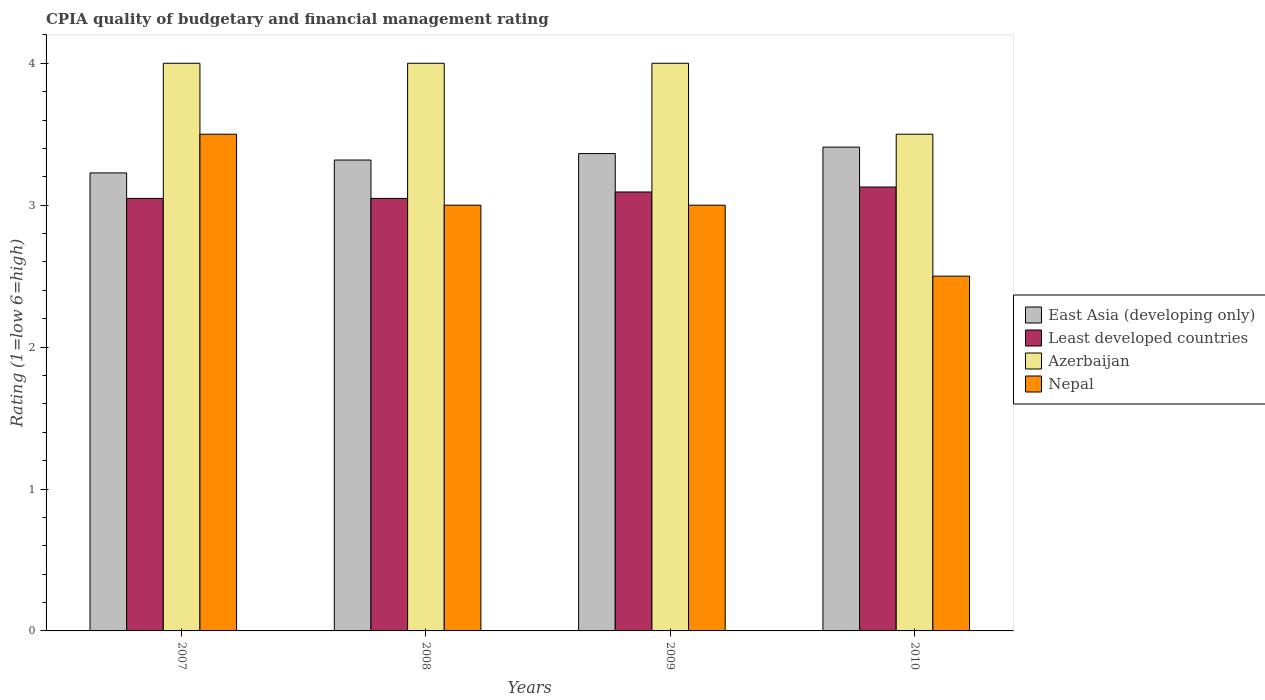How many groups of bars are there?
Provide a short and direct response. 4. Are the number of bars on each tick of the X-axis equal?
Provide a succinct answer. Yes. What is the label of the 1st group of bars from the left?
Offer a terse response. 2007. In how many cases, is the number of bars for a given year not equal to the number of legend labels?
Your response must be concise. 0. What is the CPIA rating in East Asia (developing only) in 2008?
Your answer should be very brief. 3.32. Across all years, what is the maximum CPIA rating in Least developed countries?
Your answer should be compact. 3.13. Across all years, what is the minimum CPIA rating in East Asia (developing only)?
Offer a very short reply. 3.23. In which year was the CPIA rating in Nepal minimum?
Ensure brevity in your answer.  2010. What is the total CPIA rating in Least developed countries in the graph?
Offer a terse response. 12.32. What is the difference between the CPIA rating in Least developed countries in 2008 and that in 2009?
Your response must be concise. -0.05. What is the difference between the CPIA rating in East Asia (developing only) in 2010 and the CPIA rating in Nepal in 2009?
Ensure brevity in your answer.  0.41. What is the average CPIA rating in East Asia (developing only) per year?
Give a very brief answer. 3.33. In the year 2008, what is the difference between the CPIA rating in East Asia (developing only) and CPIA rating in Least developed countries?
Make the answer very short. 0.27. What is the ratio of the CPIA rating in Least developed countries in 2009 to that in 2010?
Offer a terse response. 0.99. Is the CPIA rating in Least developed countries in 2009 less than that in 2010?
Offer a terse response. Yes. Is the difference between the CPIA rating in East Asia (developing only) in 2008 and 2010 greater than the difference between the CPIA rating in Least developed countries in 2008 and 2010?
Your answer should be compact. No. What is the difference between the highest and the lowest CPIA rating in East Asia (developing only)?
Your response must be concise. 0.18. In how many years, is the CPIA rating in East Asia (developing only) greater than the average CPIA rating in East Asia (developing only) taken over all years?
Provide a succinct answer. 2. What does the 2nd bar from the left in 2010 represents?
Your response must be concise. Least developed countries. What does the 4th bar from the right in 2009 represents?
Provide a short and direct response. East Asia (developing only). Is it the case that in every year, the sum of the CPIA rating in Least developed countries and CPIA rating in Nepal is greater than the CPIA rating in Azerbaijan?
Ensure brevity in your answer.  Yes. How many bars are there?
Keep it short and to the point. 16. How many years are there in the graph?
Your response must be concise. 4. What is the difference between two consecutive major ticks on the Y-axis?
Offer a very short reply. 1. Are the values on the major ticks of Y-axis written in scientific E-notation?
Provide a short and direct response. No. Does the graph contain any zero values?
Your response must be concise. No. How many legend labels are there?
Offer a terse response. 4. What is the title of the graph?
Offer a very short reply. CPIA quality of budgetary and financial management rating. What is the label or title of the X-axis?
Ensure brevity in your answer.  Years. What is the Rating (1=low 6=high) in East Asia (developing only) in 2007?
Keep it short and to the point. 3.23. What is the Rating (1=low 6=high) in Least developed countries in 2007?
Provide a succinct answer. 3.05. What is the Rating (1=low 6=high) of Azerbaijan in 2007?
Give a very brief answer. 4. What is the Rating (1=low 6=high) in Nepal in 2007?
Provide a short and direct response. 3.5. What is the Rating (1=low 6=high) in East Asia (developing only) in 2008?
Keep it short and to the point. 3.32. What is the Rating (1=low 6=high) in Least developed countries in 2008?
Provide a short and direct response. 3.05. What is the Rating (1=low 6=high) in Azerbaijan in 2008?
Your answer should be very brief. 4. What is the Rating (1=low 6=high) in Nepal in 2008?
Give a very brief answer. 3. What is the Rating (1=low 6=high) in East Asia (developing only) in 2009?
Give a very brief answer. 3.36. What is the Rating (1=low 6=high) in Least developed countries in 2009?
Offer a very short reply. 3.09. What is the Rating (1=low 6=high) in Azerbaijan in 2009?
Ensure brevity in your answer.  4. What is the Rating (1=low 6=high) of Nepal in 2009?
Provide a short and direct response. 3. What is the Rating (1=low 6=high) in East Asia (developing only) in 2010?
Your answer should be very brief. 3.41. What is the Rating (1=low 6=high) in Least developed countries in 2010?
Your response must be concise. 3.13. What is the Rating (1=low 6=high) of Azerbaijan in 2010?
Provide a short and direct response. 3.5. Across all years, what is the maximum Rating (1=low 6=high) in East Asia (developing only)?
Offer a very short reply. 3.41. Across all years, what is the maximum Rating (1=low 6=high) in Least developed countries?
Keep it short and to the point. 3.13. Across all years, what is the maximum Rating (1=low 6=high) in Nepal?
Offer a very short reply. 3.5. Across all years, what is the minimum Rating (1=low 6=high) of East Asia (developing only)?
Your answer should be very brief. 3.23. Across all years, what is the minimum Rating (1=low 6=high) of Least developed countries?
Offer a very short reply. 3.05. Across all years, what is the minimum Rating (1=low 6=high) in Nepal?
Offer a terse response. 2.5. What is the total Rating (1=low 6=high) of East Asia (developing only) in the graph?
Your answer should be very brief. 13.32. What is the total Rating (1=low 6=high) of Least developed countries in the graph?
Make the answer very short. 12.32. What is the total Rating (1=low 6=high) in Azerbaijan in the graph?
Offer a very short reply. 15.5. What is the total Rating (1=low 6=high) of Nepal in the graph?
Make the answer very short. 12. What is the difference between the Rating (1=low 6=high) in East Asia (developing only) in 2007 and that in 2008?
Offer a very short reply. -0.09. What is the difference between the Rating (1=low 6=high) of Azerbaijan in 2007 and that in 2008?
Provide a short and direct response. 0. What is the difference between the Rating (1=low 6=high) of Nepal in 2007 and that in 2008?
Offer a very short reply. 0.5. What is the difference between the Rating (1=low 6=high) in East Asia (developing only) in 2007 and that in 2009?
Offer a terse response. -0.14. What is the difference between the Rating (1=low 6=high) of Least developed countries in 2007 and that in 2009?
Your answer should be very brief. -0.05. What is the difference between the Rating (1=low 6=high) in Azerbaijan in 2007 and that in 2009?
Offer a very short reply. 0. What is the difference between the Rating (1=low 6=high) in East Asia (developing only) in 2007 and that in 2010?
Your answer should be very brief. -0.18. What is the difference between the Rating (1=low 6=high) of Least developed countries in 2007 and that in 2010?
Make the answer very short. -0.08. What is the difference between the Rating (1=low 6=high) in Nepal in 2007 and that in 2010?
Keep it short and to the point. 1. What is the difference between the Rating (1=low 6=high) in East Asia (developing only) in 2008 and that in 2009?
Your response must be concise. -0.05. What is the difference between the Rating (1=low 6=high) in Least developed countries in 2008 and that in 2009?
Ensure brevity in your answer.  -0.05. What is the difference between the Rating (1=low 6=high) in Azerbaijan in 2008 and that in 2009?
Provide a succinct answer. 0. What is the difference between the Rating (1=low 6=high) in East Asia (developing only) in 2008 and that in 2010?
Your answer should be compact. -0.09. What is the difference between the Rating (1=low 6=high) of Least developed countries in 2008 and that in 2010?
Provide a succinct answer. -0.08. What is the difference between the Rating (1=low 6=high) in Nepal in 2008 and that in 2010?
Ensure brevity in your answer.  0.5. What is the difference between the Rating (1=low 6=high) of East Asia (developing only) in 2009 and that in 2010?
Make the answer very short. -0.05. What is the difference between the Rating (1=low 6=high) in Least developed countries in 2009 and that in 2010?
Ensure brevity in your answer.  -0.03. What is the difference between the Rating (1=low 6=high) of Azerbaijan in 2009 and that in 2010?
Provide a short and direct response. 0.5. What is the difference between the Rating (1=low 6=high) of Nepal in 2009 and that in 2010?
Your answer should be very brief. 0.5. What is the difference between the Rating (1=low 6=high) of East Asia (developing only) in 2007 and the Rating (1=low 6=high) of Least developed countries in 2008?
Ensure brevity in your answer.  0.18. What is the difference between the Rating (1=low 6=high) of East Asia (developing only) in 2007 and the Rating (1=low 6=high) of Azerbaijan in 2008?
Provide a succinct answer. -0.77. What is the difference between the Rating (1=low 6=high) in East Asia (developing only) in 2007 and the Rating (1=low 6=high) in Nepal in 2008?
Provide a succinct answer. 0.23. What is the difference between the Rating (1=low 6=high) of Least developed countries in 2007 and the Rating (1=low 6=high) of Azerbaijan in 2008?
Your answer should be compact. -0.95. What is the difference between the Rating (1=low 6=high) in Least developed countries in 2007 and the Rating (1=low 6=high) in Nepal in 2008?
Keep it short and to the point. 0.05. What is the difference between the Rating (1=low 6=high) in Azerbaijan in 2007 and the Rating (1=low 6=high) in Nepal in 2008?
Make the answer very short. 1. What is the difference between the Rating (1=low 6=high) of East Asia (developing only) in 2007 and the Rating (1=low 6=high) of Least developed countries in 2009?
Provide a succinct answer. 0.13. What is the difference between the Rating (1=low 6=high) in East Asia (developing only) in 2007 and the Rating (1=low 6=high) in Azerbaijan in 2009?
Offer a terse response. -0.77. What is the difference between the Rating (1=low 6=high) of East Asia (developing only) in 2007 and the Rating (1=low 6=high) of Nepal in 2009?
Make the answer very short. 0.23. What is the difference between the Rating (1=low 6=high) of Least developed countries in 2007 and the Rating (1=low 6=high) of Azerbaijan in 2009?
Your answer should be very brief. -0.95. What is the difference between the Rating (1=low 6=high) in Least developed countries in 2007 and the Rating (1=low 6=high) in Nepal in 2009?
Your response must be concise. 0.05. What is the difference between the Rating (1=low 6=high) of East Asia (developing only) in 2007 and the Rating (1=low 6=high) of Least developed countries in 2010?
Your answer should be compact. 0.1. What is the difference between the Rating (1=low 6=high) of East Asia (developing only) in 2007 and the Rating (1=low 6=high) of Azerbaijan in 2010?
Your response must be concise. -0.27. What is the difference between the Rating (1=low 6=high) in East Asia (developing only) in 2007 and the Rating (1=low 6=high) in Nepal in 2010?
Provide a succinct answer. 0.73. What is the difference between the Rating (1=low 6=high) in Least developed countries in 2007 and the Rating (1=low 6=high) in Azerbaijan in 2010?
Offer a very short reply. -0.45. What is the difference between the Rating (1=low 6=high) of Least developed countries in 2007 and the Rating (1=low 6=high) of Nepal in 2010?
Offer a terse response. 0.55. What is the difference between the Rating (1=low 6=high) in Azerbaijan in 2007 and the Rating (1=low 6=high) in Nepal in 2010?
Your answer should be very brief. 1.5. What is the difference between the Rating (1=low 6=high) of East Asia (developing only) in 2008 and the Rating (1=low 6=high) of Least developed countries in 2009?
Offer a terse response. 0.23. What is the difference between the Rating (1=low 6=high) of East Asia (developing only) in 2008 and the Rating (1=low 6=high) of Azerbaijan in 2009?
Give a very brief answer. -0.68. What is the difference between the Rating (1=low 6=high) of East Asia (developing only) in 2008 and the Rating (1=low 6=high) of Nepal in 2009?
Your response must be concise. 0.32. What is the difference between the Rating (1=low 6=high) in Least developed countries in 2008 and the Rating (1=low 6=high) in Azerbaijan in 2009?
Provide a short and direct response. -0.95. What is the difference between the Rating (1=low 6=high) of Least developed countries in 2008 and the Rating (1=low 6=high) of Nepal in 2009?
Offer a very short reply. 0.05. What is the difference between the Rating (1=low 6=high) in East Asia (developing only) in 2008 and the Rating (1=low 6=high) in Least developed countries in 2010?
Your answer should be compact. 0.19. What is the difference between the Rating (1=low 6=high) in East Asia (developing only) in 2008 and the Rating (1=low 6=high) in Azerbaijan in 2010?
Give a very brief answer. -0.18. What is the difference between the Rating (1=low 6=high) in East Asia (developing only) in 2008 and the Rating (1=low 6=high) in Nepal in 2010?
Ensure brevity in your answer.  0.82. What is the difference between the Rating (1=low 6=high) of Least developed countries in 2008 and the Rating (1=low 6=high) of Azerbaijan in 2010?
Give a very brief answer. -0.45. What is the difference between the Rating (1=low 6=high) in Least developed countries in 2008 and the Rating (1=low 6=high) in Nepal in 2010?
Your answer should be compact. 0.55. What is the difference between the Rating (1=low 6=high) of Azerbaijan in 2008 and the Rating (1=low 6=high) of Nepal in 2010?
Your answer should be very brief. 1.5. What is the difference between the Rating (1=low 6=high) in East Asia (developing only) in 2009 and the Rating (1=low 6=high) in Least developed countries in 2010?
Provide a succinct answer. 0.24. What is the difference between the Rating (1=low 6=high) of East Asia (developing only) in 2009 and the Rating (1=low 6=high) of Azerbaijan in 2010?
Provide a short and direct response. -0.14. What is the difference between the Rating (1=low 6=high) of East Asia (developing only) in 2009 and the Rating (1=low 6=high) of Nepal in 2010?
Your response must be concise. 0.86. What is the difference between the Rating (1=low 6=high) in Least developed countries in 2009 and the Rating (1=low 6=high) in Azerbaijan in 2010?
Your answer should be compact. -0.41. What is the difference between the Rating (1=low 6=high) of Least developed countries in 2009 and the Rating (1=low 6=high) of Nepal in 2010?
Offer a terse response. 0.59. What is the difference between the Rating (1=low 6=high) in Azerbaijan in 2009 and the Rating (1=low 6=high) in Nepal in 2010?
Your answer should be very brief. 1.5. What is the average Rating (1=low 6=high) of East Asia (developing only) per year?
Offer a very short reply. 3.33. What is the average Rating (1=low 6=high) of Least developed countries per year?
Offer a very short reply. 3.08. What is the average Rating (1=low 6=high) in Azerbaijan per year?
Make the answer very short. 3.88. In the year 2007, what is the difference between the Rating (1=low 6=high) of East Asia (developing only) and Rating (1=low 6=high) of Least developed countries?
Provide a succinct answer. 0.18. In the year 2007, what is the difference between the Rating (1=low 6=high) in East Asia (developing only) and Rating (1=low 6=high) in Azerbaijan?
Keep it short and to the point. -0.77. In the year 2007, what is the difference between the Rating (1=low 6=high) in East Asia (developing only) and Rating (1=low 6=high) in Nepal?
Your answer should be compact. -0.27. In the year 2007, what is the difference between the Rating (1=low 6=high) in Least developed countries and Rating (1=low 6=high) in Azerbaijan?
Offer a very short reply. -0.95. In the year 2007, what is the difference between the Rating (1=low 6=high) of Least developed countries and Rating (1=low 6=high) of Nepal?
Keep it short and to the point. -0.45. In the year 2007, what is the difference between the Rating (1=low 6=high) in Azerbaijan and Rating (1=low 6=high) in Nepal?
Keep it short and to the point. 0.5. In the year 2008, what is the difference between the Rating (1=low 6=high) of East Asia (developing only) and Rating (1=low 6=high) of Least developed countries?
Provide a succinct answer. 0.27. In the year 2008, what is the difference between the Rating (1=low 6=high) of East Asia (developing only) and Rating (1=low 6=high) of Azerbaijan?
Give a very brief answer. -0.68. In the year 2008, what is the difference between the Rating (1=low 6=high) in East Asia (developing only) and Rating (1=low 6=high) in Nepal?
Your answer should be compact. 0.32. In the year 2008, what is the difference between the Rating (1=low 6=high) of Least developed countries and Rating (1=low 6=high) of Azerbaijan?
Offer a terse response. -0.95. In the year 2008, what is the difference between the Rating (1=low 6=high) in Least developed countries and Rating (1=low 6=high) in Nepal?
Keep it short and to the point. 0.05. In the year 2008, what is the difference between the Rating (1=low 6=high) of Azerbaijan and Rating (1=low 6=high) of Nepal?
Provide a succinct answer. 1. In the year 2009, what is the difference between the Rating (1=low 6=high) of East Asia (developing only) and Rating (1=low 6=high) of Least developed countries?
Offer a very short reply. 0.27. In the year 2009, what is the difference between the Rating (1=low 6=high) of East Asia (developing only) and Rating (1=low 6=high) of Azerbaijan?
Your response must be concise. -0.64. In the year 2009, what is the difference between the Rating (1=low 6=high) of East Asia (developing only) and Rating (1=low 6=high) of Nepal?
Make the answer very short. 0.36. In the year 2009, what is the difference between the Rating (1=low 6=high) of Least developed countries and Rating (1=low 6=high) of Azerbaijan?
Provide a short and direct response. -0.91. In the year 2009, what is the difference between the Rating (1=low 6=high) in Least developed countries and Rating (1=low 6=high) in Nepal?
Your answer should be very brief. 0.09. In the year 2009, what is the difference between the Rating (1=low 6=high) of Azerbaijan and Rating (1=low 6=high) of Nepal?
Offer a terse response. 1. In the year 2010, what is the difference between the Rating (1=low 6=high) in East Asia (developing only) and Rating (1=low 6=high) in Least developed countries?
Offer a very short reply. 0.28. In the year 2010, what is the difference between the Rating (1=low 6=high) of East Asia (developing only) and Rating (1=low 6=high) of Azerbaijan?
Offer a very short reply. -0.09. In the year 2010, what is the difference between the Rating (1=low 6=high) in East Asia (developing only) and Rating (1=low 6=high) in Nepal?
Offer a very short reply. 0.91. In the year 2010, what is the difference between the Rating (1=low 6=high) of Least developed countries and Rating (1=low 6=high) of Azerbaijan?
Provide a short and direct response. -0.37. In the year 2010, what is the difference between the Rating (1=low 6=high) in Least developed countries and Rating (1=low 6=high) in Nepal?
Your answer should be compact. 0.63. In the year 2010, what is the difference between the Rating (1=low 6=high) in Azerbaijan and Rating (1=low 6=high) in Nepal?
Offer a terse response. 1. What is the ratio of the Rating (1=low 6=high) in East Asia (developing only) in 2007 to that in 2008?
Your response must be concise. 0.97. What is the ratio of the Rating (1=low 6=high) in Nepal in 2007 to that in 2008?
Offer a very short reply. 1.17. What is the ratio of the Rating (1=low 6=high) in East Asia (developing only) in 2007 to that in 2009?
Your answer should be very brief. 0.96. What is the ratio of the Rating (1=low 6=high) in Least developed countries in 2007 to that in 2009?
Provide a succinct answer. 0.99. What is the ratio of the Rating (1=low 6=high) in Azerbaijan in 2007 to that in 2009?
Offer a terse response. 1. What is the ratio of the Rating (1=low 6=high) of Nepal in 2007 to that in 2009?
Provide a succinct answer. 1.17. What is the ratio of the Rating (1=low 6=high) in East Asia (developing only) in 2007 to that in 2010?
Provide a succinct answer. 0.95. What is the ratio of the Rating (1=low 6=high) of Least developed countries in 2007 to that in 2010?
Provide a succinct answer. 0.97. What is the ratio of the Rating (1=low 6=high) in Nepal in 2007 to that in 2010?
Provide a succinct answer. 1.4. What is the ratio of the Rating (1=low 6=high) in East Asia (developing only) in 2008 to that in 2009?
Provide a succinct answer. 0.99. What is the ratio of the Rating (1=low 6=high) in East Asia (developing only) in 2008 to that in 2010?
Give a very brief answer. 0.97. What is the ratio of the Rating (1=low 6=high) in Least developed countries in 2008 to that in 2010?
Offer a terse response. 0.97. What is the ratio of the Rating (1=low 6=high) of Azerbaijan in 2008 to that in 2010?
Your response must be concise. 1.14. What is the ratio of the Rating (1=low 6=high) in East Asia (developing only) in 2009 to that in 2010?
Provide a short and direct response. 0.99. What is the ratio of the Rating (1=low 6=high) of Nepal in 2009 to that in 2010?
Offer a terse response. 1.2. What is the difference between the highest and the second highest Rating (1=low 6=high) of East Asia (developing only)?
Give a very brief answer. 0.05. What is the difference between the highest and the second highest Rating (1=low 6=high) of Least developed countries?
Offer a very short reply. 0.03. What is the difference between the highest and the second highest Rating (1=low 6=high) of Nepal?
Your response must be concise. 0.5. What is the difference between the highest and the lowest Rating (1=low 6=high) of East Asia (developing only)?
Offer a terse response. 0.18. What is the difference between the highest and the lowest Rating (1=low 6=high) of Least developed countries?
Ensure brevity in your answer.  0.08. 